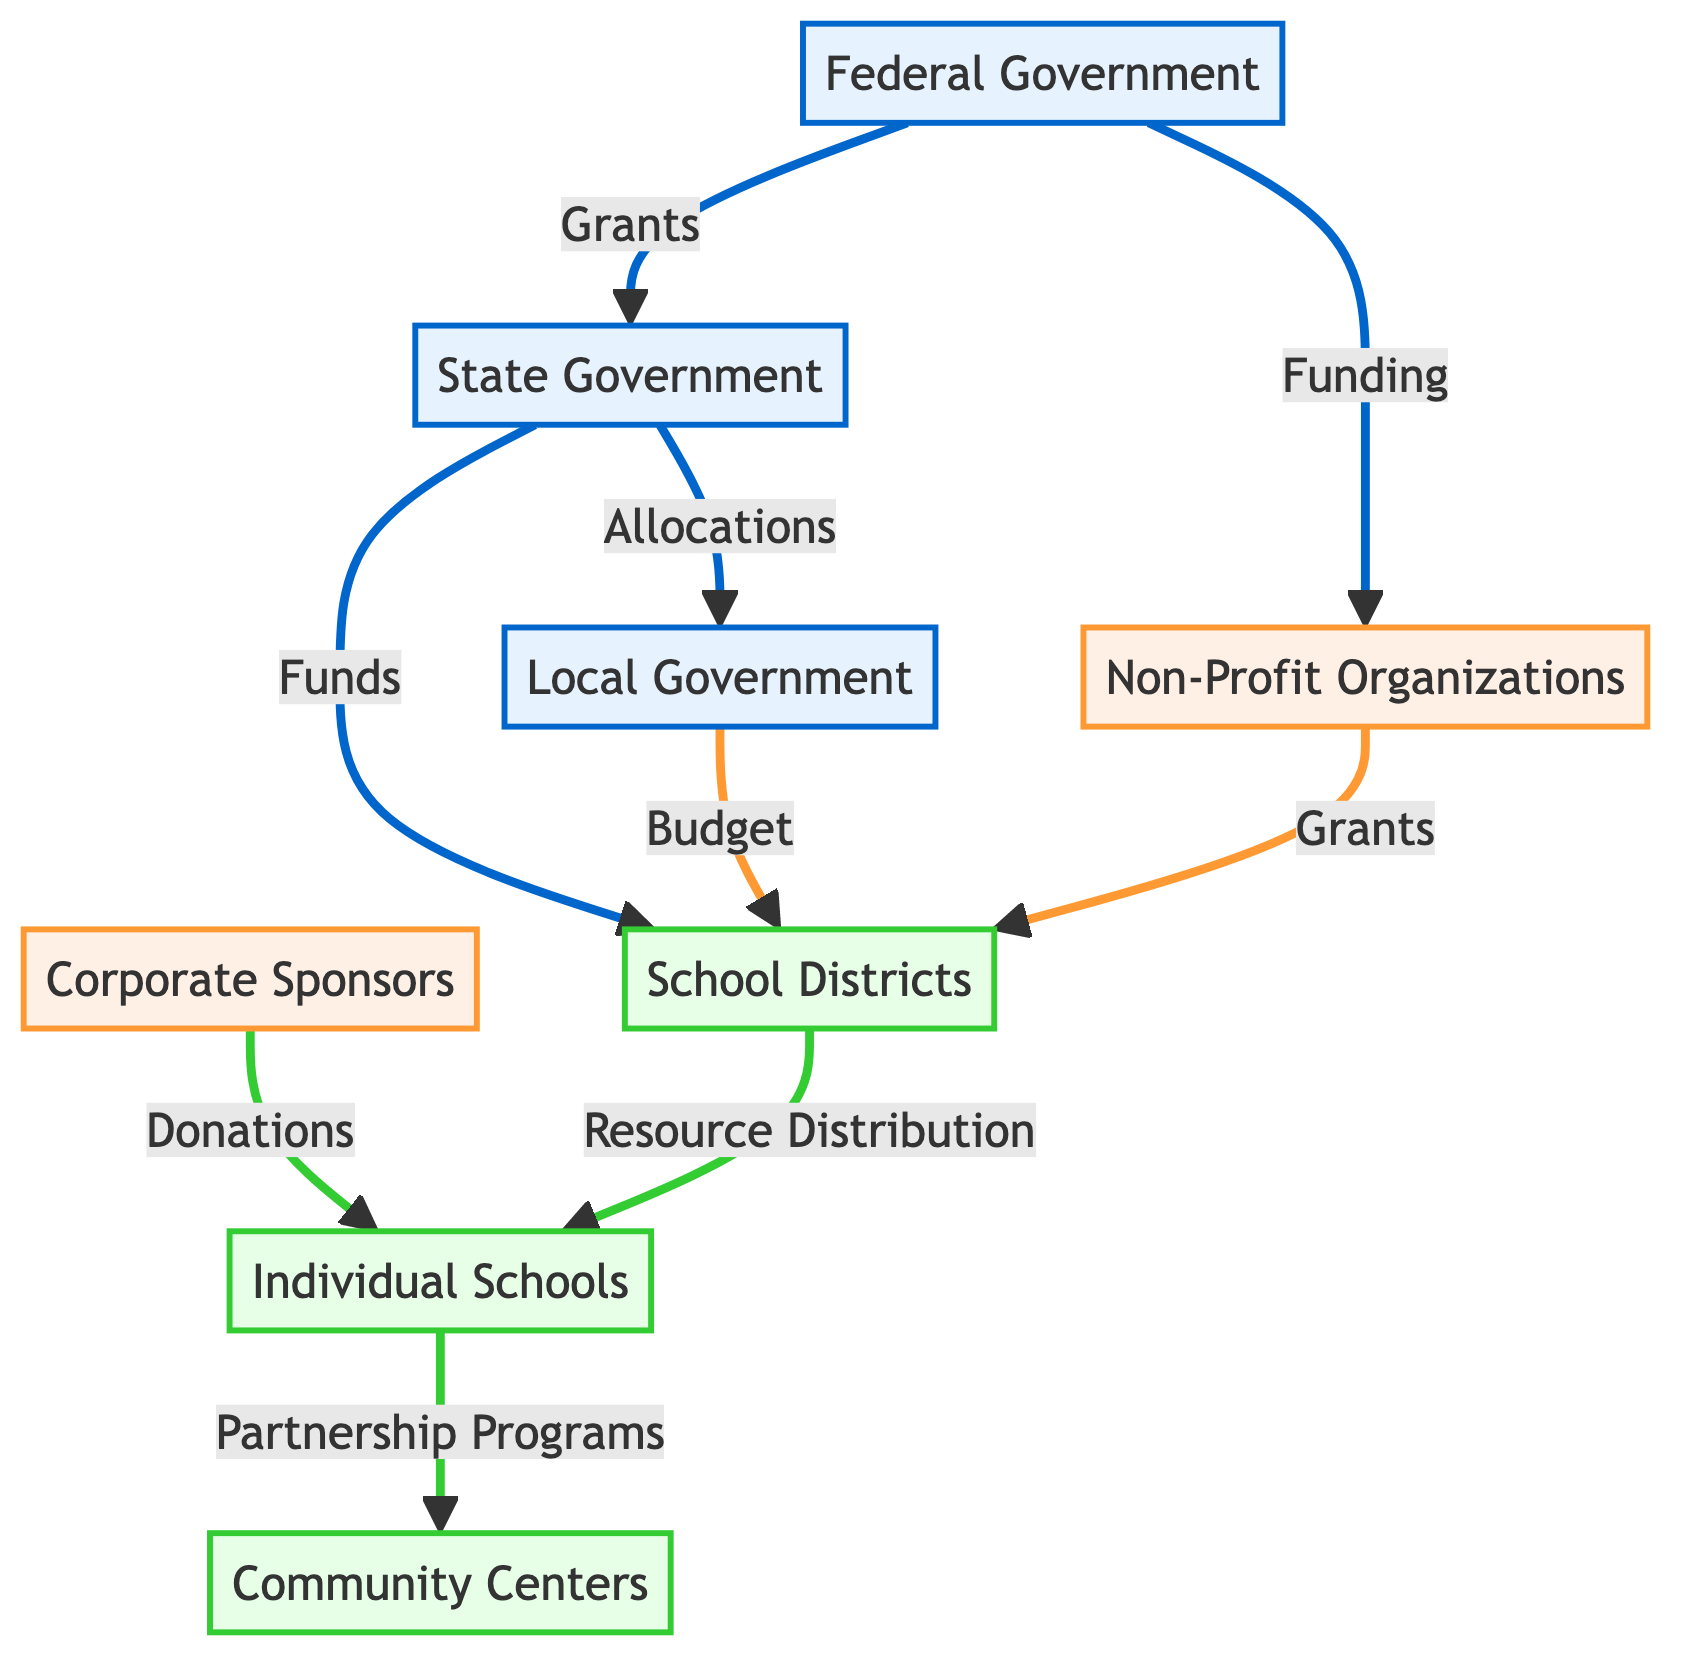What is the total number of nodes in the diagram? The diagram lists eight distinct entities: Federal Government, State Government, Local Government, Non-Profit Organizations, Corporate Sponsors, School Districts, Individual Schools, and Community Centers. Therefore, counting these gives a total of eight nodes.
Answer: 8 Which organization receives funding directly from the Federal Government? The diagram indicates that there are two entities connected to the Federal Government through edges labeled "Grants" and "Funding". Non-Profit Organizations are specifically linked with "Funding", showing they receive resources directly from Federal Government.
Answer: Non-Profit Organizations How do State Governments allocate resources to School Districts? The diagram reveals an edge from State Government to School Districts labeled "Funds". This indicates that State Governments allocate resources directly to School Districts through these funds.
Answer: Funds What is the relationship between Individual Schools and Community Centers? An edge connecting Individual Schools and Community Centers shows a "Partnership Programs" relationship, indicating the nature of collaboration or resource sharing between these two entities.
Answer: Partnership Programs Which two entities are responsible for distributing resources to Individual Schools? The diagram shows edges leading to Individual Schools from School Districts and Corporate Sponsors. This indicates that both entities play a role in resource distribution to Individual Schools.
Answer: School Districts and Corporate Sponsors What type of programs flow from Individual Schools to Community Centers? The relationship expressed by the edge indicates that "Partnership Programs" are the type of collaboration flowing from Individual Schools to Community Centers, suggesting joint initiatives or support.
Answer: Partnership Programs How many edges are there connecting Local Government to School Districts? The diagram points out that there is a single edge labelled "Budget" from Local Government to School Districts, indicating a direct financial relationship. Therefore, there is one edge in this context.
Answer: 1 What type of funding does the Federal Government provide to State Governments? The edge connecting Federal Government to State Government is labeled "Grants", which details the specific type of funding provided at that level.
Answer: Grants 